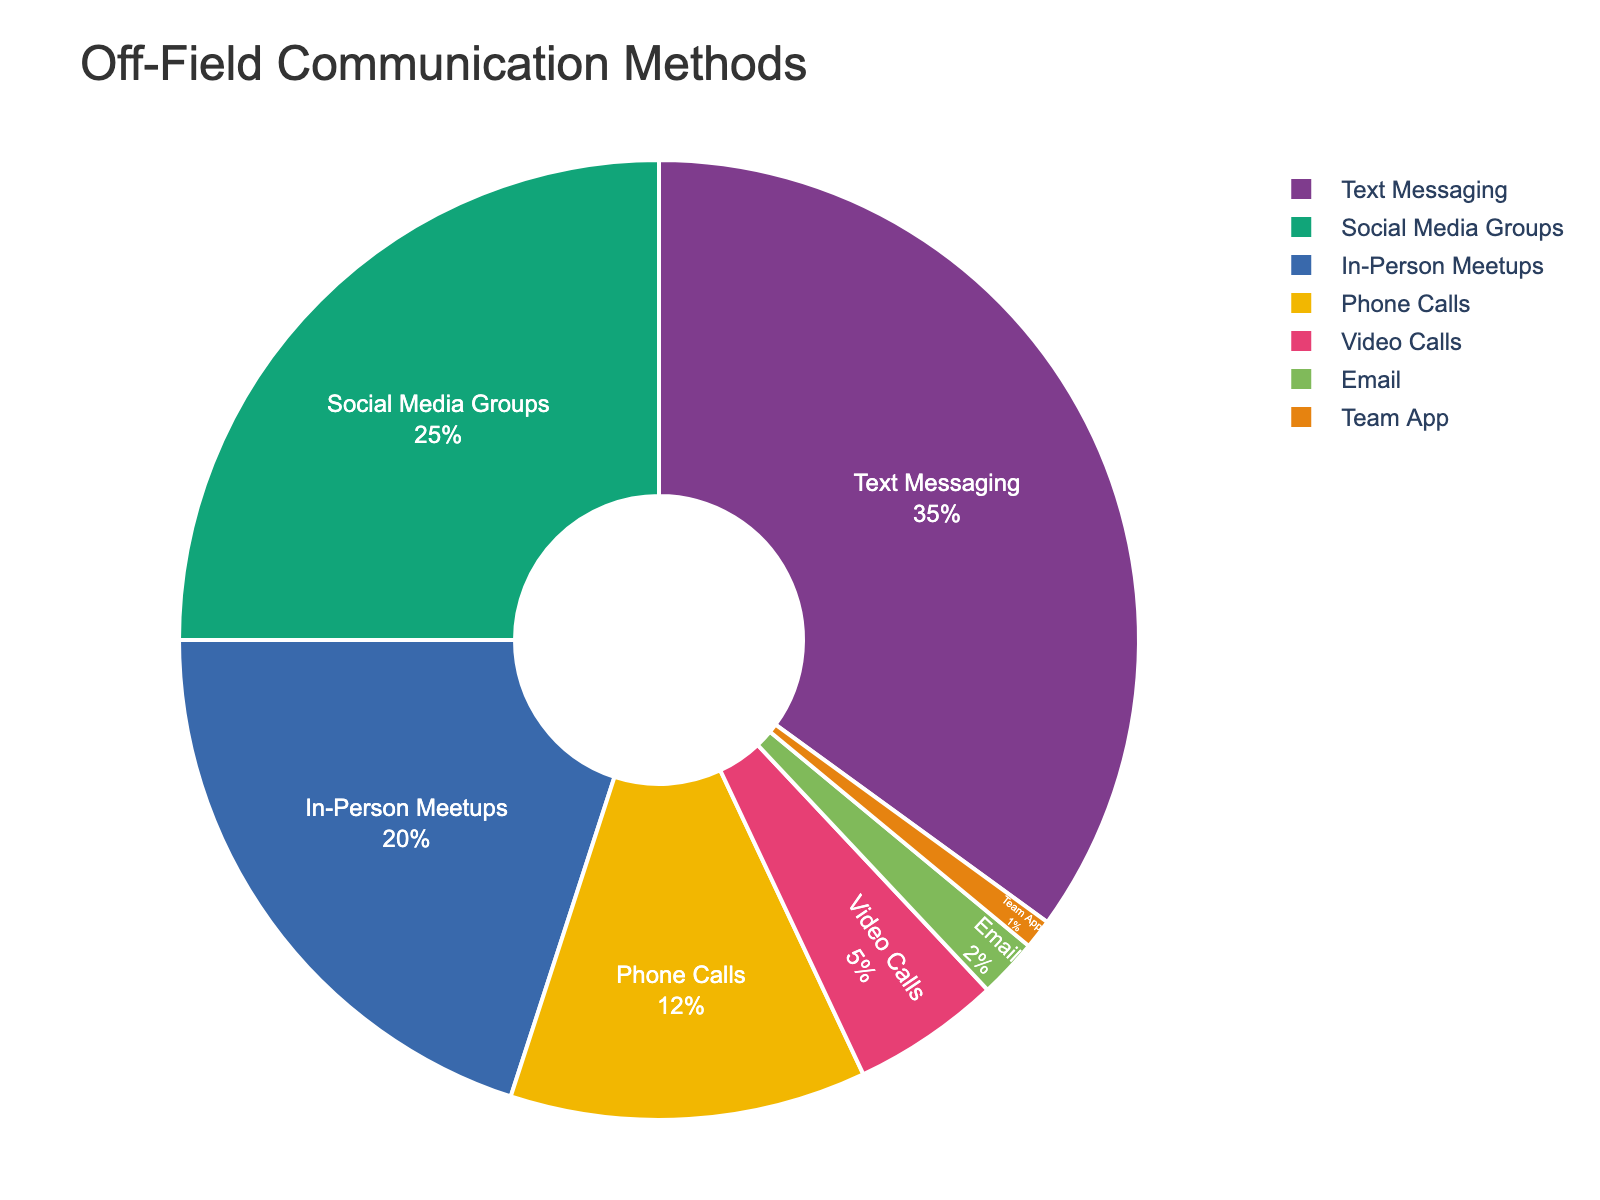How many off-field communication methods make up less than 5% each? Count the segments that have percentages less than 5%. These are Video Calls, Email, and Team App which total to 3 methods.
Answer: 3 What is the combined percentage of the two least used communication methods? Identify the two smallest segments: Team App (1%) and Email (2%). Add their percentages, 1% + 2% = 3%.
Answer: 3% Which communication method is the most popular? Look for the segment with the highest percentage. Text Messaging has the highest share at 35%.
Answer: Text Messaging Are In-Person Meetups used more frequently than Phone Calls? Compare the percentages of In-Person Meetups (20%) and Phone Calls (12%). Since 20% is greater than 12%, In-Person Meetups are used more frequently.
Answer: Yes What is the difference in percentage points between Social Media Groups and Video Calls? Find the percentages for Social Media Groups (25%) and Video Calls (5%). Subtract the smaller percentage from the larger one: 25% - 5% = 20%.
Answer: 20% If Text Messaging and Social Media Groups are combined, what is their total percentage? Add the percentages of Text Messaging (35%) and Social Media Groups (25%): 35% + 25% = 60%.
Answer: 60% Which communication methods have a percentage that is equal or greater than 10%? Look for segments with 10% or more: Text Messaging (35%), Social Media Groups (25%), In-Person Meetups (20%), and Phone Calls (12%).
Answer: Text Messaging, Social Media Groups, In-Person Meetups, Phone Calls Between Email and Team App, which one is used less for communication? Compare the percentages of Email (2%) and Team App (1%) and see which is smaller. Team App is smaller at 1%.
Answer: Team App What percentage of team members prefer in-person interactions including In-Person Meetups and any other method that involves face-to-face communication? Adding the percentage for In-Person Meetups (20%) since it implies face-to-face communication. No other methods clearly specify face-to-face interaction, so the percentage remains the same.
Answer: 20% What is the ratio of the percentage of Text Messaging to the percentage of Phone Calls? Calculate the ratio by dividing Text Messaging (35%) by Phone Calls (12%): 35% / 12% = 2.9167, or approximately 2.92 when rounded to two decimal places.
Answer: 2.92 